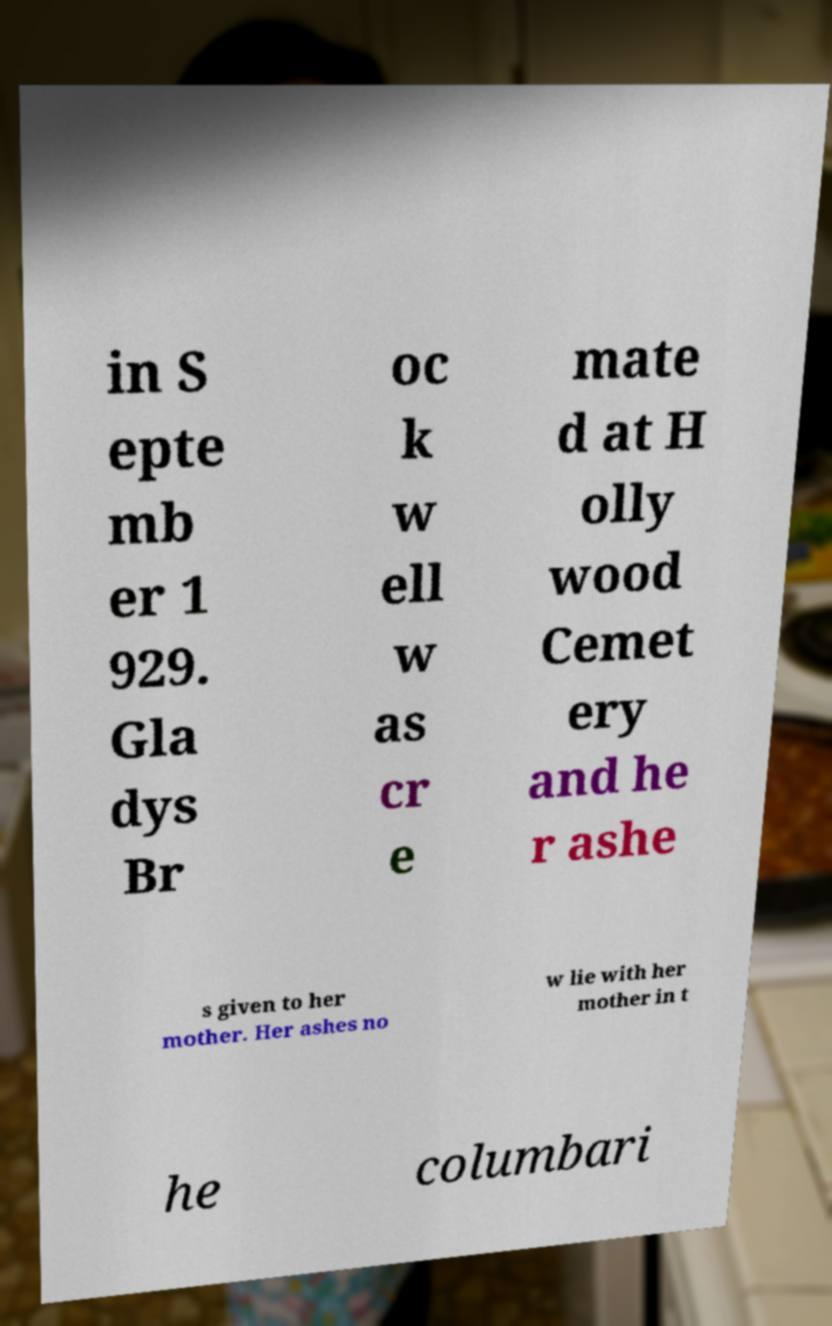For documentation purposes, I need the text within this image transcribed. Could you provide that? in S epte mb er 1 929. Gla dys Br oc k w ell w as cr e mate d at H olly wood Cemet ery and he r ashe s given to her mother. Her ashes no w lie with her mother in t he columbari 